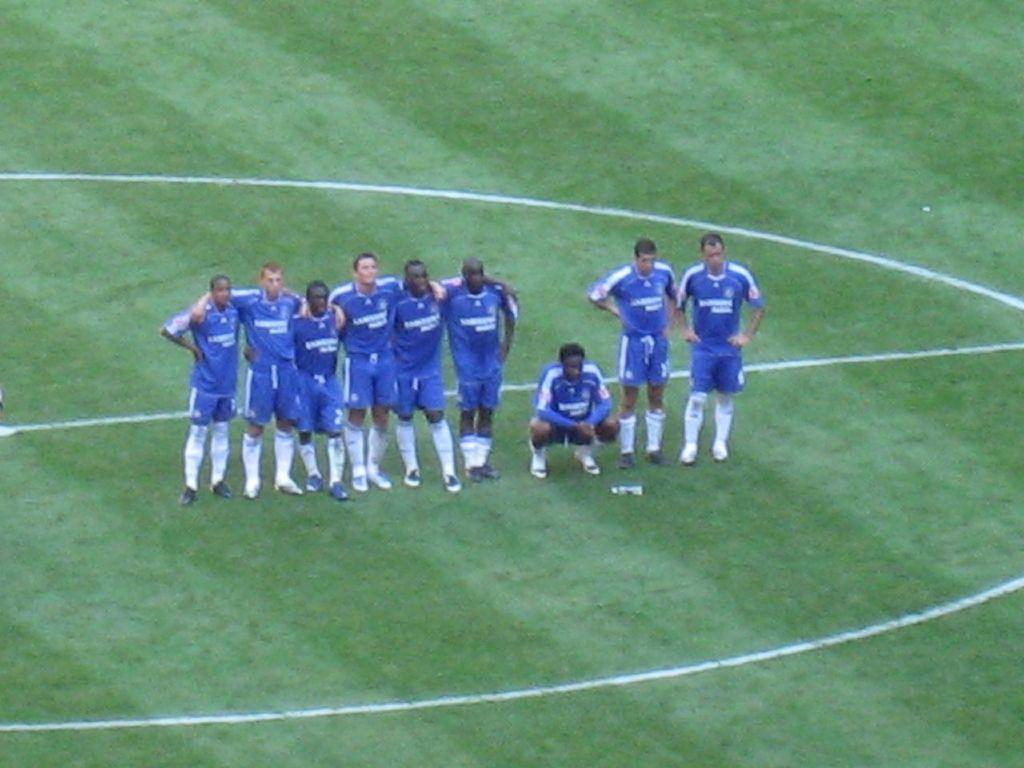Describe this image in one or two sentences. This picture might be taken inside a playground. In this image in the middle, we can see group of people standing on the grass, we can also see a man is in squat position in the middle. In the background, there is green color. 